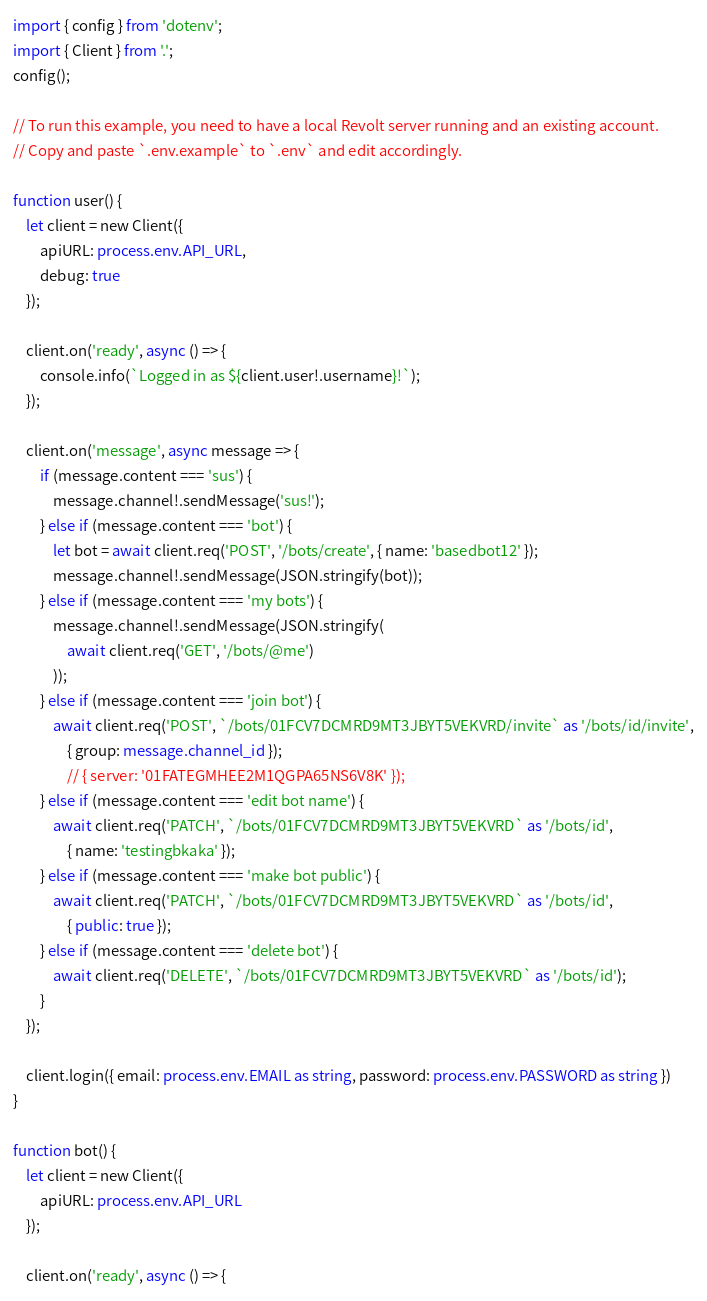Convert code to text. <code><loc_0><loc_0><loc_500><loc_500><_TypeScript_>import { config } from 'dotenv';
import { Client } from '.';
config();

// To run this example, you need to have a local Revolt server running and an existing account.
// Copy and paste `.env.example` to `.env` and edit accordingly.

function user() {
    let client = new Client({
        apiURL: process.env.API_URL,
        debug: true
    });

    client.on('ready', async () => {
        console.info(`Logged in as ${client.user!.username}!`);
    });

    client.on('message', async message => {
        if (message.content === 'sus') {
            message.channel!.sendMessage('sus!');
        } else if (message.content === 'bot') {
            let bot = await client.req('POST', '/bots/create', { name: 'basedbot12' });
            message.channel!.sendMessage(JSON.stringify(bot));
        } else if (message.content === 'my bots') {
            message.channel!.sendMessage(JSON.stringify(
                await client.req('GET', '/bots/@me')
            ));
        } else if (message.content === 'join bot') {
            await client.req('POST', `/bots/01FCV7DCMRD9MT3JBYT5VEKVRD/invite` as '/bots/id/invite',
                { group: message.channel_id });
                // { server: '01FATEGMHEE2M1QGPA65NS6V8K' });
        } else if (message.content === 'edit bot name') {
            await client.req('PATCH', `/bots/01FCV7DCMRD9MT3JBYT5VEKVRD` as '/bots/id',
                { name: 'testingbkaka' });
        } else if (message.content === 'make bot public') {
            await client.req('PATCH', `/bots/01FCV7DCMRD9MT3JBYT5VEKVRD` as '/bots/id',
                { public: true });
        } else if (message.content === 'delete bot') {
            await client.req('DELETE', `/bots/01FCV7DCMRD9MT3JBYT5VEKVRD` as '/bots/id');
        }
    });

    client.login({ email: process.env.EMAIL as string, password: process.env.PASSWORD as string })
}

function bot() {
    let client = new Client({
        apiURL: process.env.API_URL
    });

    client.on('ready', async () => {</code> 